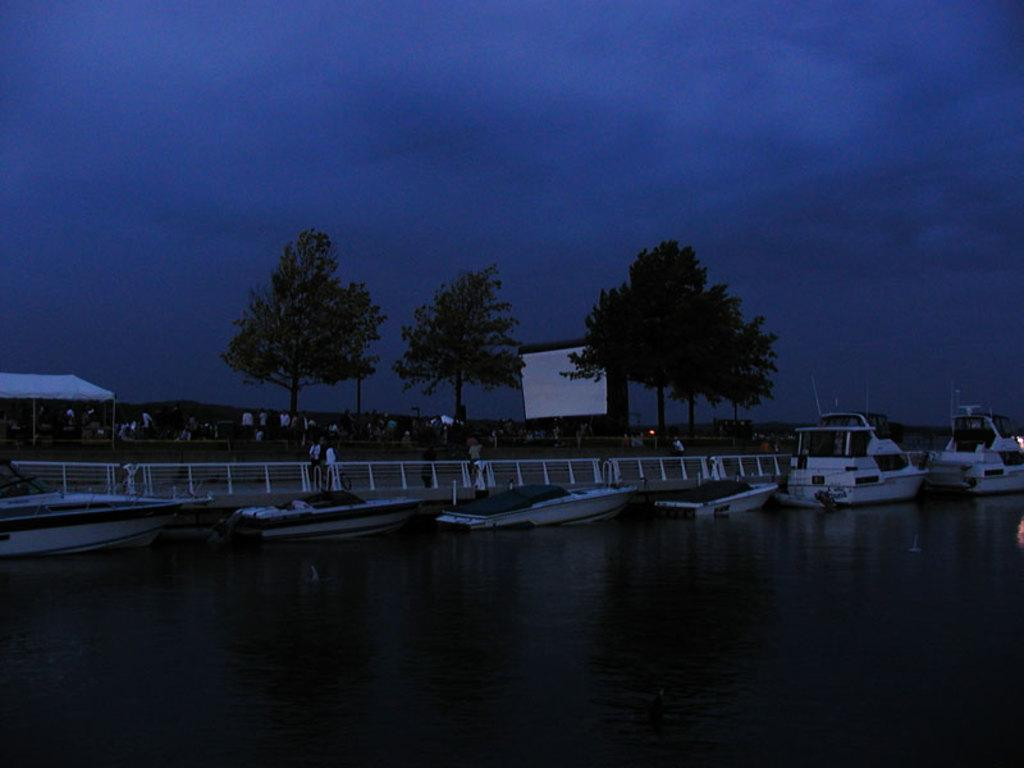What can be seen in the center of the image? The sky is visible in the center of the image. What type of natural elements are present in the image? There are trees in the image. What are the boats doing in the image? Boats are present on the water. What type of structures can be seen in the image? Fences are in the image. What type of shelter is present in the image? There is a tent in the image. Are there any people in the image? Yes, there are people in the image. Can you describe any other objects in the image? There are other unspecified objects in the image. What color is the pencil used by the person in the image? There is no pencil present in the image. How much milk is being poured by the person in the image? There is no milk or person pouring milk in the image. 